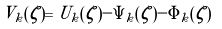<formula> <loc_0><loc_0><loc_500><loc_500>V _ { k } ( \zeta ) = U _ { k } ( \zeta ) - \Psi _ { k } ( \zeta ) - \Phi _ { k } ( \zeta )</formula> 